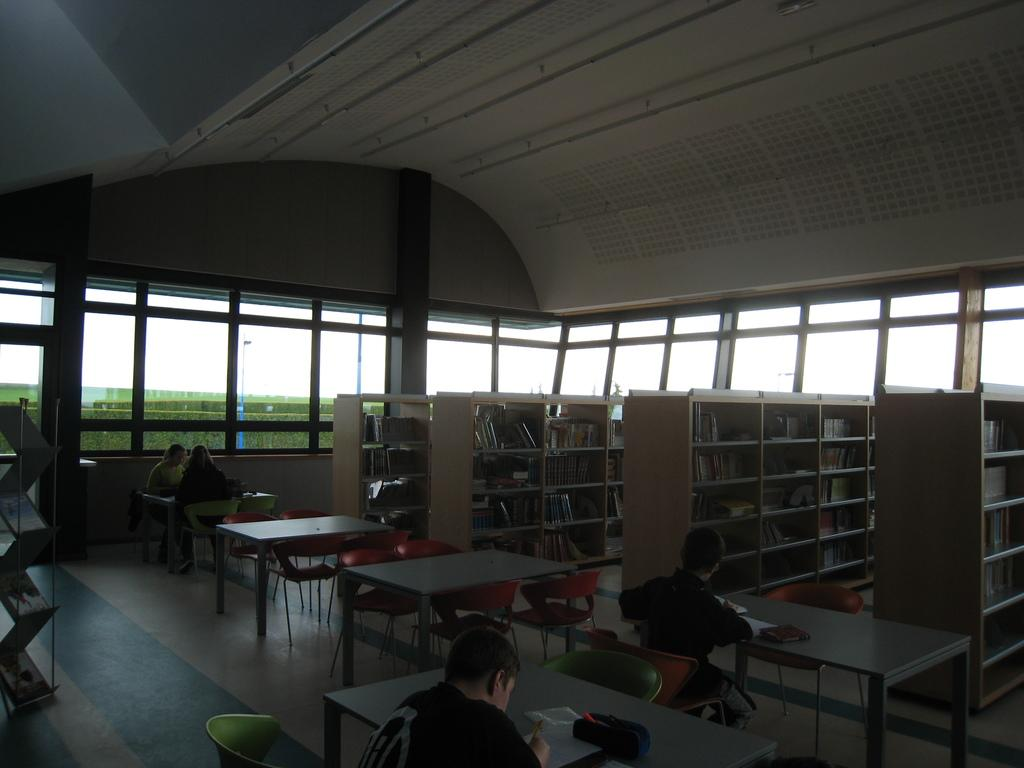What type of setting is shown in the image? The image depicts a library setting. Can you describe the person in the image? There is a person sitting on a chair in the image. What is the person doing in the image? The person is writing in a book on a table. What can be seen on the walls of the library? There are bookshelves in the image. What is the condition of the windows in the library? There are glass windows in the image. What can be seen outside the library through the windows? Trees are visible outside the windows. Where is the toothbrush located in the image? There is no toothbrush present in the image. What type of religious building can be seen outside the library? There is no church or any religious building visible in the image. 